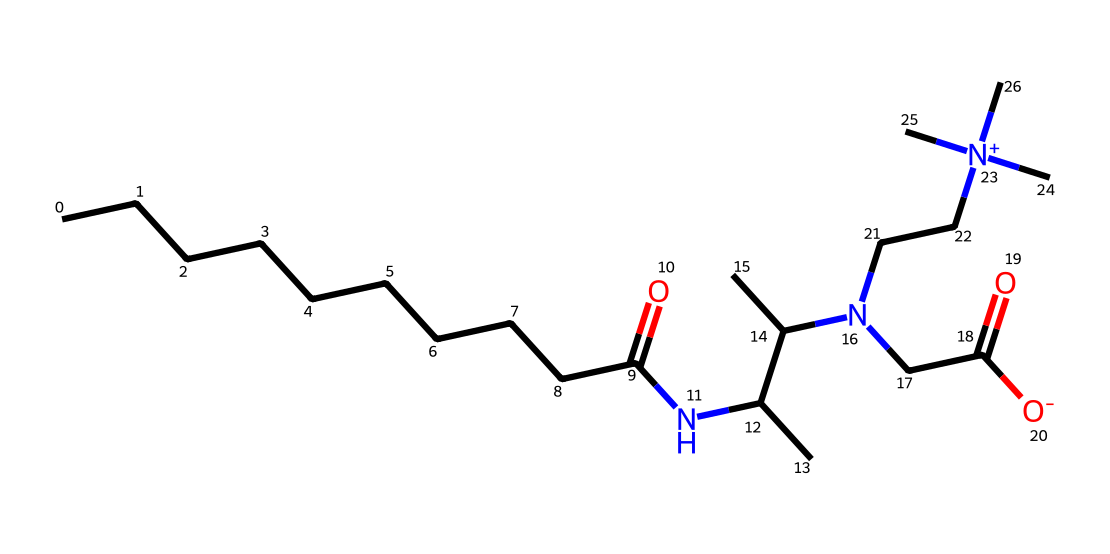What is the carbon chain length in cocamidopropyl betaine? The SMILES indicates a long hydrocarbon chain (CCCCCCCCCC) which contains 10 carbon atoms in the tail. Thus, the carbon chain length is 10.
Answer: 10 How many nitrogen atoms are present in cocamidopropyl betaine? By analyzing the SMILES representation, we can identify two nitrogen atoms in the structure due to the N and [N+] symbols present.
Answer: 2 What functional group is present in cocamidopropyl betaine that contributes to its surfactant properties? The carboxylate functional group (indicated by the CC(=O)[O-] part) plays a significant role in its surfactant nature, providing the log n-octanol/water partitioning characteristic necessary for detergency.
Answer: carboxylate What type of surfactant is cocamidopropyl betaine considered? Considering the structure contains both hydrophilic (due to the betaine group) and hydrophobic segments, it can be classified as a zwitterionic surfactant that is gentle on skin and hair.
Answer: zwitterionic What is the role of the hydrocarbon tail in cocamidopropyl betaine? The hydrocarbon tail (10 carbon chain) is hydrophobic and helps in reducing the surface tension of water, aiding in the emulsification and cleaning processes, which is crucial in its application as a detergent.
Answer: hydrophobic What is the total number of oxygen atoms in cocamidopropyl betaine? By examining the structure in the SMILES, we can find a total of three oxygen atoms: two from the carboxylate group and one from the amide linkage.
Answer: 3 